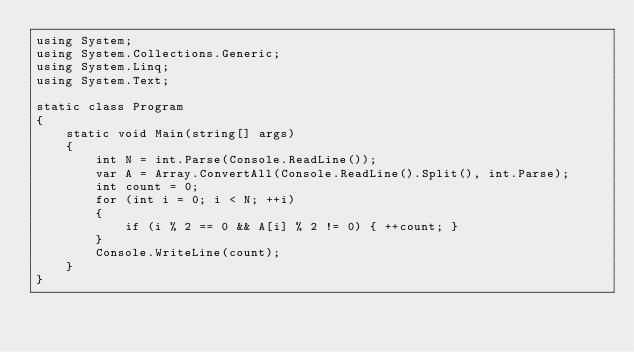<code> <loc_0><loc_0><loc_500><loc_500><_C#_>using System;
using System.Collections.Generic;
using System.Linq;
using System.Text;

static class Program
{
    static void Main(string[] args)
    {
        int N = int.Parse(Console.ReadLine());
        var A = Array.ConvertAll(Console.ReadLine().Split(), int.Parse);
        int count = 0;
        for (int i = 0; i < N; ++i)
        {
            if (i % 2 == 0 && A[i] % 2 != 0) { ++count; }
        }
        Console.WriteLine(count);
    }
}
</code> 